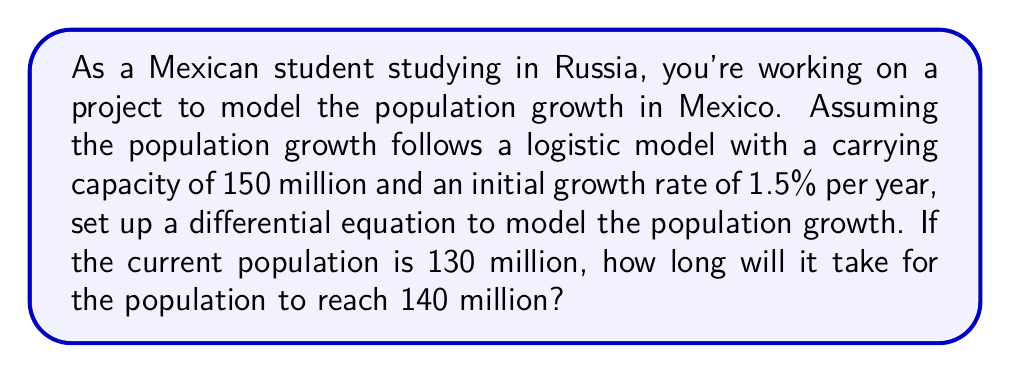Show me your answer to this math problem. Let's approach this step-by-step:

1) The logistic growth model is given by the differential equation:

   $$\frac{dP}{dt} = rP(1-\frac{P}{K})$$

   where $P$ is the population, $t$ is time, $r$ is the growth rate, and $K$ is the carrying capacity.

2) We're given:
   $K = 150$ million
   $r = 0.015$ (1.5% per year)
   Initial $P = 130$ million

3) Substituting these values into the equation:

   $$\frac{dP}{dt} = 0.015P(1-\frac{P}{150})$$

4) To find the time it takes to reach 140 million, we need to integrate this equation:

   $$\int_{130}^{140} \frac{dP}{P(1-\frac{P}{150})} = \int_0^t 0.015 dt$$

5) The left side of this equation can be solved using partial fractions:

   $$\left[-\ln|P| + 150\ln|150-P|\right]_{130}^{140} = 0.015t$$

6) Evaluating the left side:

   $$(-\ln(140) + 150\ln(10)) - (-\ln(130) + 150\ln(20)) = 0.015t$$

7) Solving for $t$:

   $$t = \frac{-\ln(140) + 150\ln(10) + \ln(130) - 150\ln(20)}{0.015} \approx 6.93$$

Therefore, it will take approximately 6.93 years for the population to grow from 130 million to 140 million.
Answer: 6.93 years 